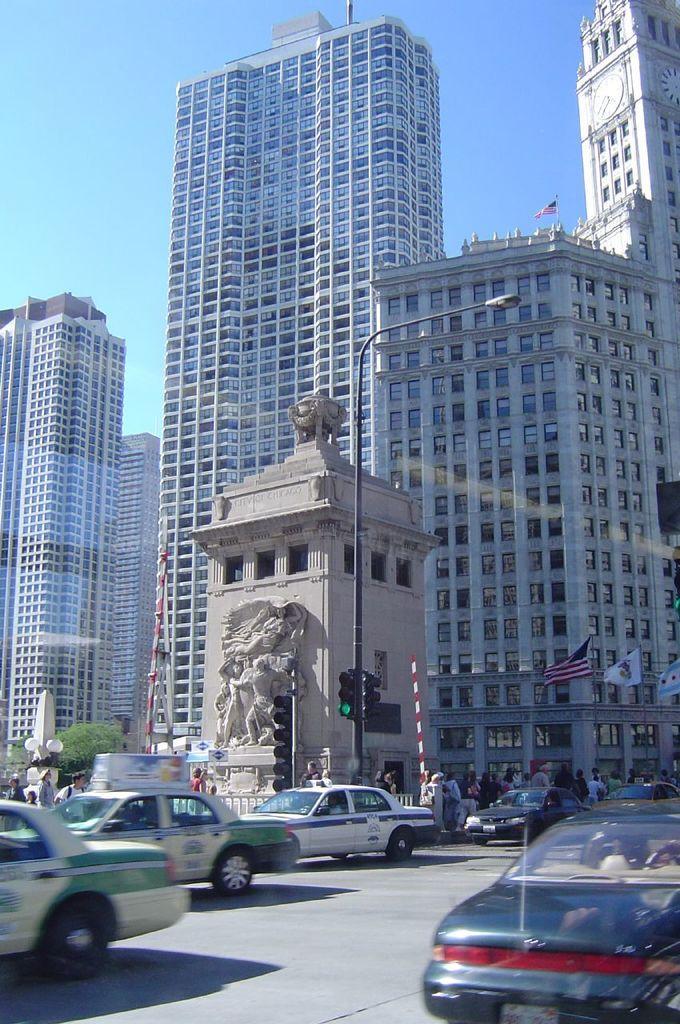Please provide a concise description of this image. In this image there are some vehicles on the road, and also there are some persons and flags. In the center there is a statue and traffic signals, in the background there are some trees and skyscrapers. At the top of the image there is sky and at the bottom there is road. 